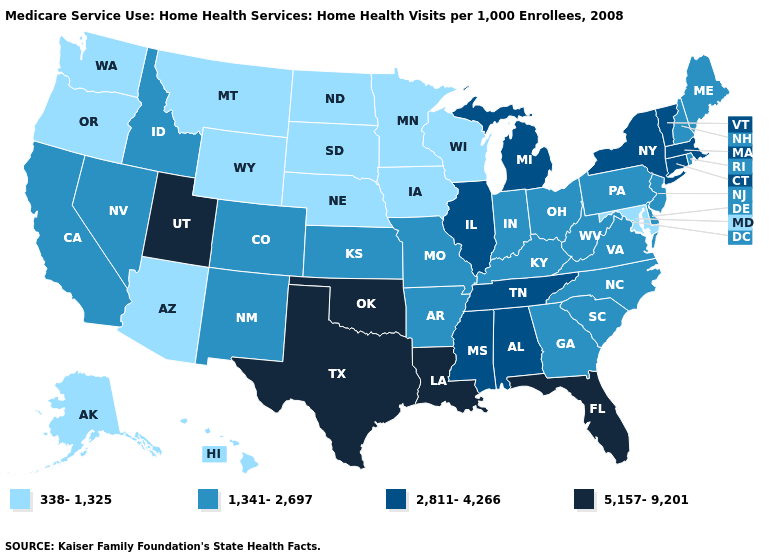Among the states that border Michigan , does Indiana have the highest value?
Be succinct. Yes. What is the value of South Carolina?
Write a very short answer. 1,341-2,697. Does Illinois have a higher value than Utah?
Answer briefly. No. What is the lowest value in the South?
Keep it brief. 338-1,325. Is the legend a continuous bar?
Answer briefly. No. Does Pennsylvania have the lowest value in the USA?
Write a very short answer. No. What is the value of North Carolina?
Concise answer only. 1,341-2,697. How many symbols are there in the legend?
Quick response, please. 4. Name the states that have a value in the range 2,811-4,266?
Quick response, please. Alabama, Connecticut, Illinois, Massachusetts, Michigan, Mississippi, New York, Tennessee, Vermont. Does the map have missing data?
Concise answer only. No. What is the value of Wisconsin?
Concise answer only. 338-1,325. Does the first symbol in the legend represent the smallest category?
Keep it brief. Yes. Which states have the lowest value in the USA?
Answer briefly. Alaska, Arizona, Hawaii, Iowa, Maryland, Minnesota, Montana, Nebraska, North Dakota, Oregon, South Dakota, Washington, Wisconsin, Wyoming. What is the lowest value in states that border North Dakota?
Write a very short answer. 338-1,325. What is the value of New Mexico?
Short answer required. 1,341-2,697. 